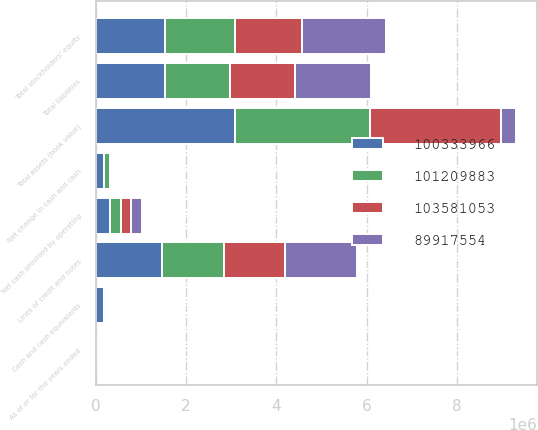<chart> <loc_0><loc_0><loc_500><loc_500><stacked_bar_chart><ecel><fcel>As of or for the years ended<fcel>Total assets (book value)<fcel>Cash and cash equivalents<fcel>Lines of credit and notes<fcel>Total liabilities<fcel>Total stockholders' equity<fcel>Net cash provided by operating<fcel>Net change in cash and cash<nl><fcel>8.99176e+07<fcel>2010<fcel>318169<fcel>17607<fcel>1.6e+06<fcel>1.68862e+06<fcel>1.84696e+06<fcel>243368<fcel>7581<nl><fcel>1.03581e+08<fcel>2009<fcel>2.91479e+06<fcel>10026<fcel>1.3546e+06<fcel>1.42678e+06<fcel>1.48801e+06<fcel>226707<fcel>36789<nl><fcel>1.0121e+08<fcel>2008<fcel>2.99418e+06<fcel>46815<fcel>1.37e+06<fcel>1.43952e+06<fcel>1.55466e+06<fcel>246155<fcel>146286<nl><fcel>1.00334e+08<fcel>2007<fcel>3.07735e+06<fcel>193101<fcel>1.47e+06<fcel>1.53926e+06<fcel>1.53809e+06<fcel>318169<fcel>182528<nl></chart> 